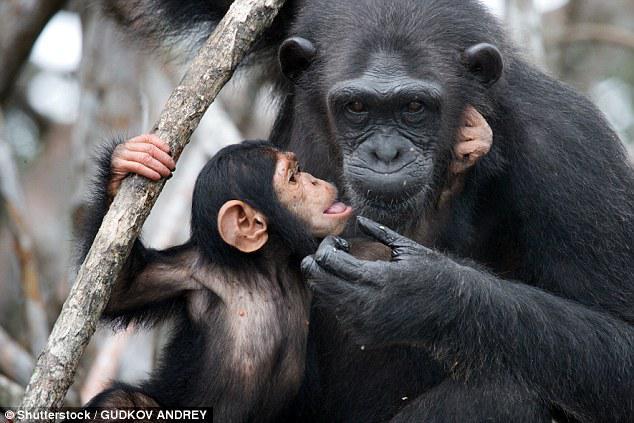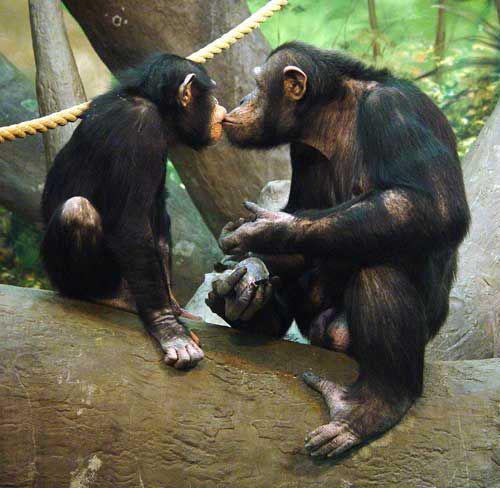The first image is the image on the left, the second image is the image on the right. Given the left and right images, does the statement "Both images show a pair of chimps with their mouths very close together." hold true? Answer yes or no. Yes. The first image is the image on the left, the second image is the image on the right. Considering the images on both sides, is "In one of the pictures, two primates kissing each other on the lips, and in the other, a baby primate is next to an adult." valid? Answer yes or no. Yes. 